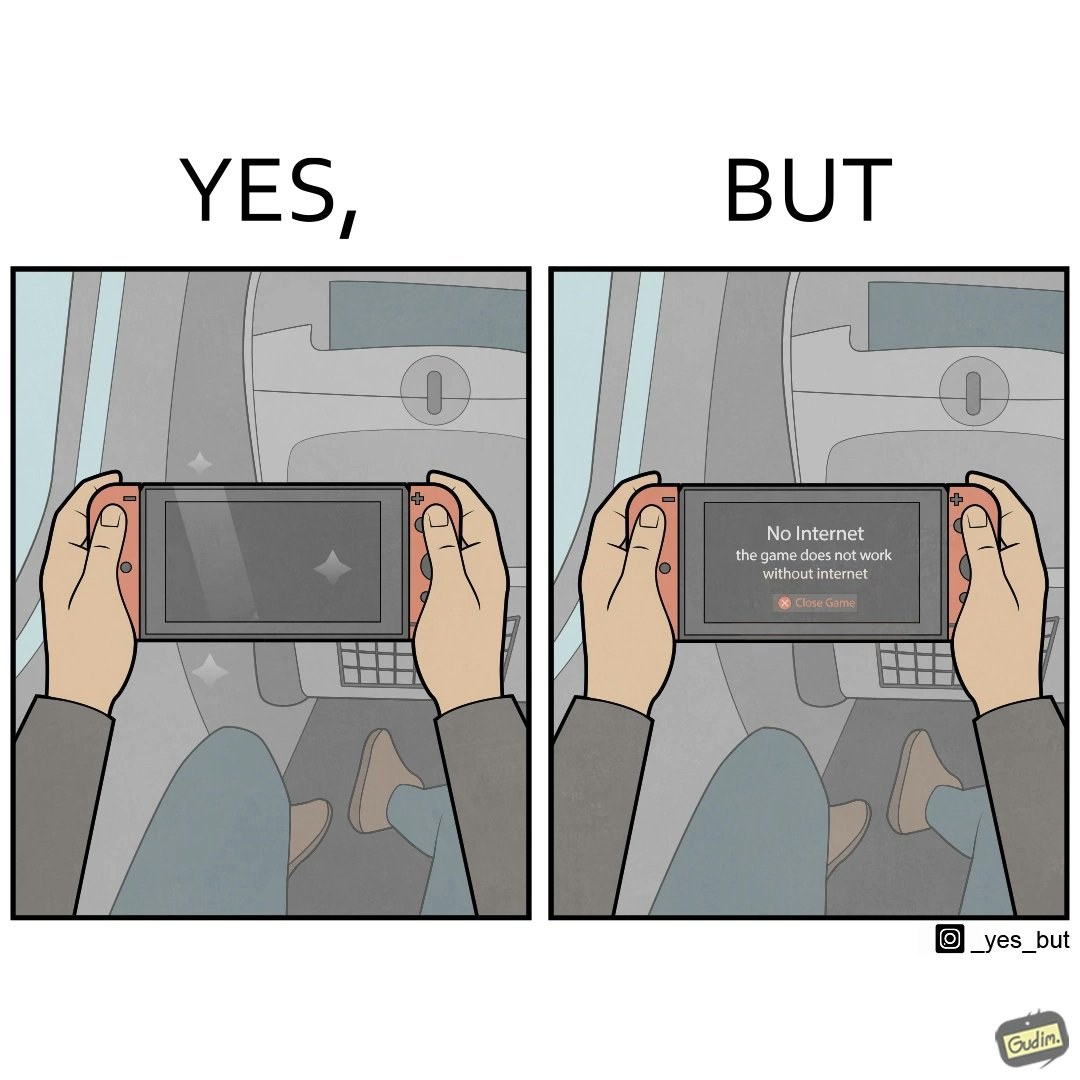Describe what you see in this image. The image is ironic, as the person is holding the game console to play a game during the flight. However, the person is unable to play the game, as the game requires internet (as is the case with many modern games), and internet is unavailable in many lights. 